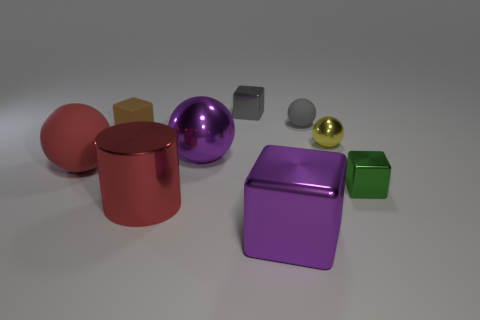Subtract all green blocks. How many blocks are left? 3 Add 1 large gray balls. How many objects exist? 10 Subtract all purple blocks. How many blocks are left? 3 Subtract 1 cylinders. How many cylinders are left? 0 Subtract all cubes. How many objects are left? 5 Add 3 big metallic things. How many big metallic things exist? 6 Subtract 1 purple blocks. How many objects are left? 8 Subtract all gray blocks. Subtract all yellow spheres. How many blocks are left? 3 Subtract all yellow cylinders. How many gray spheres are left? 1 Subtract all gray matte cylinders. Subtract all small rubber blocks. How many objects are left? 8 